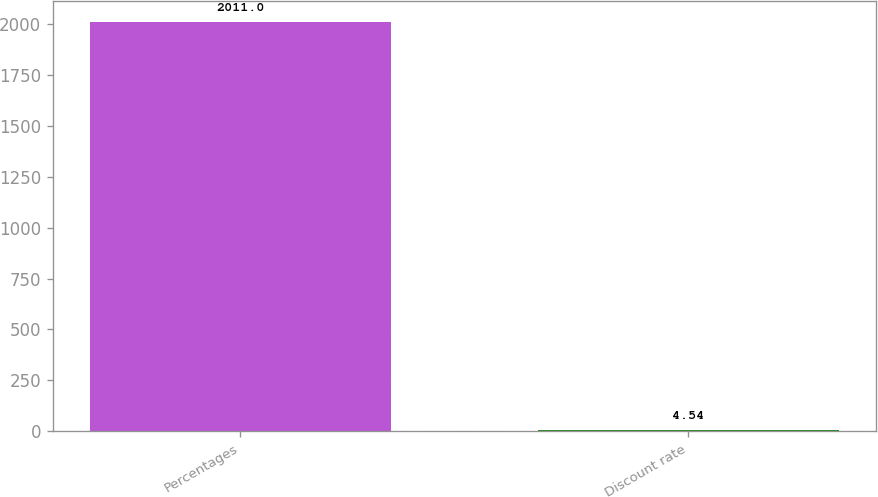<chart> <loc_0><loc_0><loc_500><loc_500><bar_chart><fcel>Percentages<fcel>Discount rate<nl><fcel>2011<fcel>4.54<nl></chart> 